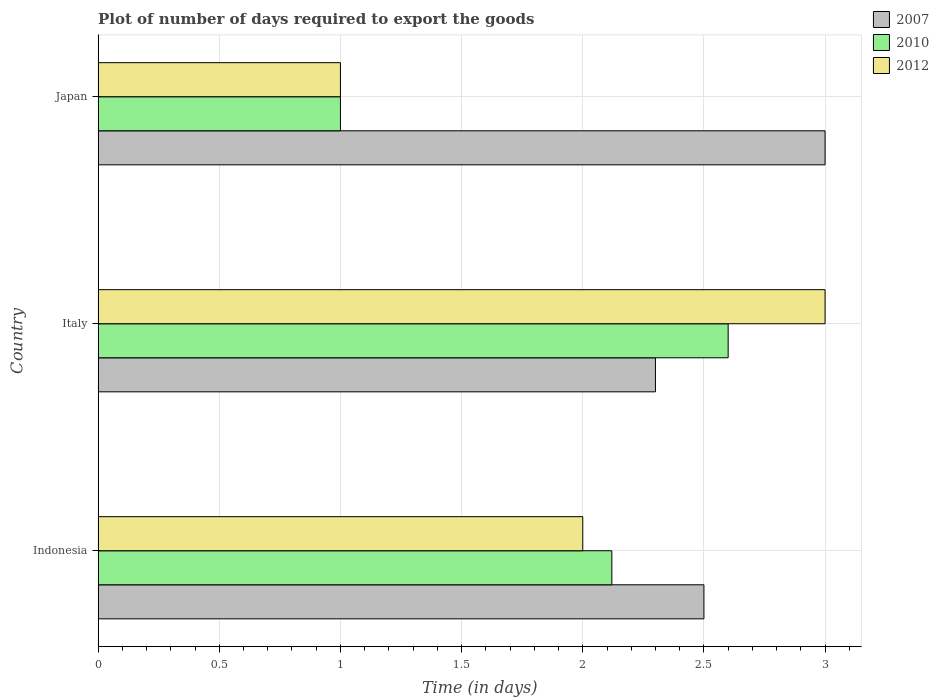How many different coloured bars are there?
Offer a terse response. 3. How many groups of bars are there?
Keep it short and to the point. 3. Are the number of bars per tick equal to the number of legend labels?
Keep it short and to the point. Yes. Are the number of bars on each tick of the Y-axis equal?
Ensure brevity in your answer.  Yes. How many bars are there on the 1st tick from the bottom?
Offer a terse response. 3. What is the label of the 2nd group of bars from the top?
Provide a short and direct response. Italy. What is the time required to export goods in 2007 in Italy?
Your answer should be very brief. 2.3. Across all countries, what is the maximum time required to export goods in 2012?
Your answer should be very brief. 3. Across all countries, what is the minimum time required to export goods in 2010?
Ensure brevity in your answer.  1. In which country was the time required to export goods in 2010 maximum?
Give a very brief answer. Italy. In which country was the time required to export goods in 2007 minimum?
Give a very brief answer. Italy. What is the total time required to export goods in 2010 in the graph?
Ensure brevity in your answer.  5.72. What is the difference between the time required to export goods in 2007 in Indonesia and that in Italy?
Provide a succinct answer. 0.2. What is the average time required to export goods in 2007 per country?
Offer a very short reply. 2.6. What is the difference between the time required to export goods in 2012 and time required to export goods in 2007 in Indonesia?
Keep it short and to the point. -0.5. In how many countries, is the time required to export goods in 2012 greater than the average time required to export goods in 2012 taken over all countries?
Offer a terse response. 1. Is the sum of the time required to export goods in 2012 in Indonesia and Japan greater than the maximum time required to export goods in 2007 across all countries?
Give a very brief answer. No. What does the 1st bar from the top in Italy represents?
Your response must be concise. 2012. What does the 1st bar from the bottom in Indonesia represents?
Your answer should be very brief. 2007. Is it the case that in every country, the sum of the time required to export goods in 2007 and time required to export goods in 2010 is greater than the time required to export goods in 2012?
Offer a terse response. Yes. Are all the bars in the graph horizontal?
Provide a short and direct response. Yes. What is the difference between two consecutive major ticks on the X-axis?
Your answer should be very brief. 0.5. Are the values on the major ticks of X-axis written in scientific E-notation?
Make the answer very short. No. What is the title of the graph?
Your response must be concise. Plot of number of days required to export the goods. What is the label or title of the X-axis?
Provide a succinct answer. Time (in days). What is the label or title of the Y-axis?
Provide a succinct answer. Country. What is the Time (in days) of 2010 in Indonesia?
Offer a terse response. 2.12. What is the Time (in days) of 2012 in Indonesia?
Offer a terse response. 2. What is the Time (in days) in 2010 in Japan?
Give a very brief answer. 1. Across all countries, what is the minimum Time (in days) of 2010?
Give a very brief answer. 1. Across all countries, what is the minimum Time (in days) in 2012?
Ensure brevity in your answer.  1. What is the total Time (in days) in 2007 in the graph?
Your answer should be compact. 7.8. What is the total Time (in days) of 2010 in the graph?
Make the answer very short. 5.72. What is the total Time (in days) in 2012 in the graph?
Your response must be concise. 6. What is the difference between the Time (in days) of 2007 in Indonesia and that in Italy?
Your answer should be compact. 0.2. What is the difference between the Time (in days) in 2010 in Indonesia and that in Italy?
Ensure brevity in your answer.  -0.48. What is the difference between the Time (in days) of 2010 in Indonesia and that in Japan?
Your answer should be very brief. 1.12. What is the difference between the Time (in days) of 2012 in Italy and that in Japan?
Keep it short and to the point. 2. What is the difference between the Time (in days) of 2007 in Indonesia and the Time (in days) of 2010 in Italy?
Offer a terse response. -0.1. What is the difference between the Time (in days) in 2010 in Indonesia and the Time (in days) in 2012 in Italy?
Keep it short and to the point. -0.88. What is the difference between the Time (in days) in 2007 in Indonesia and the Time (in days) in 2012 in Japan?
Offer a terse response. 1.5. What is the difference between the Time (in days) in 2010 in Indonesia and the Time (in days) in 2012 in Japan?
Offer a very short reply. 1.12. What is the difference between the Time (in days) in 2007 in Italy and the Time (in days) in 2010 in Japan?
Provide a short and direct response. 1.3. What is the difference between the Time (in days) in 2010 in Italy and the Time (in days) in 2012 in Japan?
Keep it short and to the point. 1.6. What is the average Time (in days) of 2010 per country?
Ensure brevity in your answer.  1.91. What is the difference between the Time (in days) of 2007 and Time (in days) of 2010 in Indonesia?
Give a very brief answer. 0.38. What is the difference between the Time (in days) of 2010 and Time (in days) of 2012 in Indonesia?
Provide a succinct answer. 0.12. What is the difference between the Time (in days) of 2010 and Time (in days) of 2012 in Italy?
Ensure brevity in your answer.  -0.4. What is the difference between the Time (in days) of 2007 and Time (in days) of 2012 in Japan?
Ensure brevity in your answer.  2. What is the difference between the Time (in days) in 2010 and Time (in days) in 2012 in Japan?
Your answer should be very brief. 0. What is the ratio of the Time (in days) of 2007 in Indonesia to that in Italy?
Your answer should be very brief. 1.09. What is the ratio of the Time (in days) in 2010 in Indonesia to that in Italy?
Give a very brief answer. 0.82. What is the ratio of the Time (in days) of 2012 in Indonesia to that in Italy?
Your answer should be very brief. 0.67. What is the ratio of the Time (in days) of 2010 in Indonesia to that in Japan?
Provide a short and direct response. 2.12. What is the ratio of the Time (in days) of 2007 in Italy to that in Japan?
Your answer should be compact. 0.77. What is the ratio of the Time (in days) in 2012 in Italy to that in Japan?
Your answer should be very brief. 3. What is the difference between the highest and the second highest Time (in days) in 2007?
Provide a succinct answer. 0.5. What is the difference between the highest and the second highest Time (in days) in 2010?
Your answer should be compact. 0.48. What is the difference between the highest and the lowest Time (in days) in 2007?
Give a very brief answer. 0.7. What is the difference between the highest and the lowest Time (in days) of 2010?
Ensure brevity in your answer.  1.6. What is the difference between the highest and the lowest Time (in days) of 2012?
Make the answer very short. 2. 